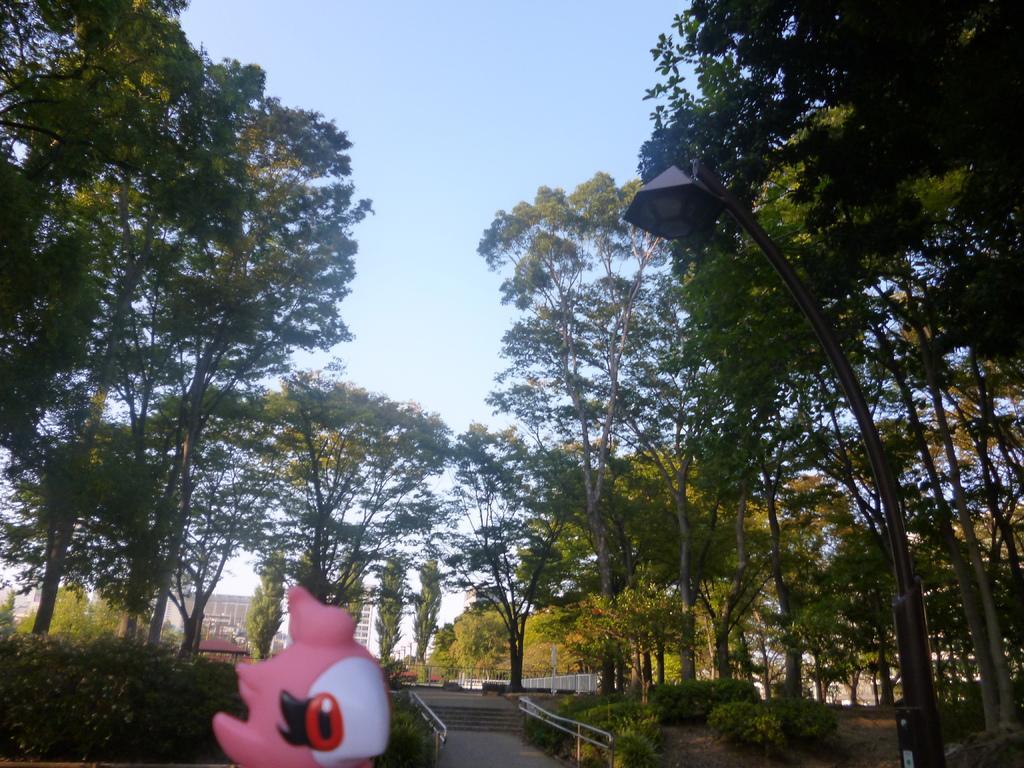How would you summarize this image in a sentence or two? At the bottom of the image we can see a toy, in the background we can find few trees, metal rods and buildings. 